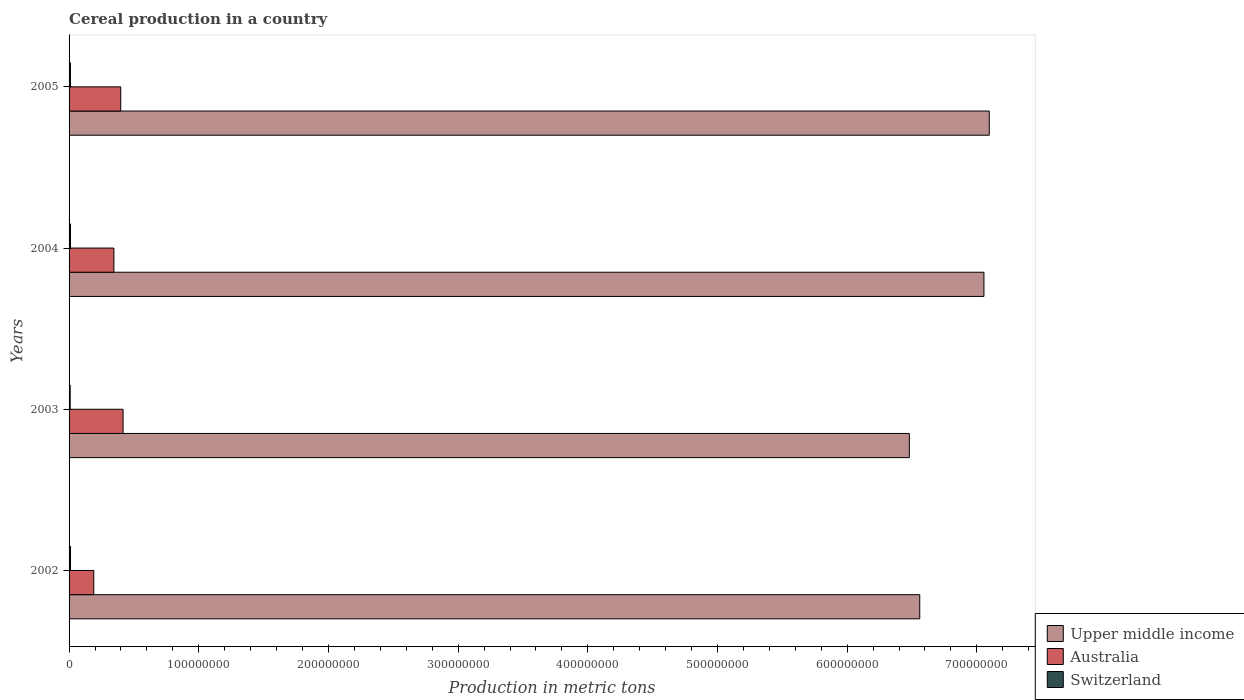How many different coloured bars are there?
Your response must be concise. 3. Are the number of bars on each tick of the Y-axis equal?
Offer a terse response. Yes. How many bars are there on the 2nd tick from the top?
Make the answer very short. 3. How many bars are there on the 2nd tick from the bottom?
Make the answer very short. 3. What is the total cereal production in Australia in 2003?
Provide a short and direct response. 4.16e+07. Across all years, what is the maximum total cereal production in Australia?
Ensure brevity in your answer.  4.16e+07. Across all years, what is the minimum total cereal production in Australia?
Offer a very short reply. 1.90e+07. What is the total total cereal production in Upper middle income in the graph?
Keep it short and to the point. 2.72e+09. What is the difference between the total cereal production in Switzerland in 2003 and that in 2005?
Give a very brief answer. -2.09e+05. What is the difference between the total cereal production in Upper middle income in 2003 and the total cereal production in Switzerland in 2002?
Your answer should be very brief. 6.47e+08. What is the average total cereal production in Switzerland per year?
Your answer should be very brief. 1.02e+06. In the year 2005, what is the difference between the total cereal production in Upper middle income and total cereal production in Australia?
Provide a short and direct response. 6.70e+08. What is the ratio of the total cereal production in Australia in 2004 to that in 2005?
Keep it short and to the point. 0.87. Is the total cereal production in Switzerland in 2002 less than that in 2005?
Your answer should be very brief. No. Is the difference between the total cereal production in Upper middle income in 2002 and 2004 greater than the difference between the total cereal production in Australia in 2002 and 2004?
Offer a very short reply. No. What is the difference between the highest and the second highest total cereal production in Switzerland?
Your answer should be compact. 1.20e+04. What is the difference between the highest and the lowest total cereal production in Upper middle income?
Keep it short and to the point. 6.16e+07. Is the sum of the total cereal production in Australia in 2002 and 2003 greater than the maximum total cereal production in Upper middle income across all years?
Offer a very short reply. No. What does the 3rd bar from the top in 2002 represents?
Provide a succinct answer. Upper middle income. What does the 2nd bar from the bottom in 2005 represents?
Keep it short and to the point. Australia. Is it the case that in every year, the sum of the total cereal production in Switzerland and total cereal production in Upper middle income is greater than the total cereal production in Australia?
Make the answer very short. Yes. Are all the bars in the graph horizontal?
Provide a short and direct response. Yes. How many years are there in the graph?
Your response must be concise. 4. Are the values on the major ticks of X-axis written in scientific E-notation?
Provide a short and direct response. No. Does the graph contain any zero values?
Make the answer very short. No. Does the graph contain grids?
Make the answer very short. No. Where does the legend appear in the graph?
Your answer should be compact. Bottom right. How many legend labels are there?
Ensure brevity in your answer.  3. How are the legend labels stacked?
Give a very brief answer. Vertical. What is the title of the graph?
Give a very brief answer. Cereal production in a country. Does "Timor-Leste" appear as one of the legend labels in the graph?
Make the answer very short. No. What is the label or title of the X-axis?
Your response must be concise. Production in metric tons. What is the Production in metric tons in Upper middle income in 2002?
Offer a terse response. 6.56e+08. What is the Production in metric tons in Australia in 2002?
Offer a terse response. 1.90e+07. What is the Production in metric tons of Switzerland in 2002?
Your response must be concise. 1.10e+06. What is the Production in metric tons in Upper middle income in 2003?
Offer a very short reply. 6.48e+08. What is the Production in metric tons in Australia in 2003?
Offer a very short reply. 4.16e+07. What is the Production in metric tons of Switzerland in 2003?
Ensure brevity in your answer.  8.47e+05. What is the Production in metric tons of Upper middle income in 2004?
Keep it short and to the point. 7.05e+08. What is the Production in metric tons in Australia in 2004?
Offer a very short reply. 3.46e+07. What is the Production in metric tons of Switzerland in 2004?
Offer a terse response. 1.09e+06. What is the Production in metric tons in Upper middle income in 2005?
Ensure brevity in your answer.  7.10e+08. What is the Production in metric tons of Australia in 2005?
Offer a terse response. 3.98e+07. What is the Production in metric tons in Switzerland in 2005?
Keep it short and to the point. 1.06e+06. Across all years, what is the maximum Production in metric tons in Upper middle income?
Your answer should be compact. 7.10e+08. Across all years, what is the maximum Production in metric tons in Australia?
Keep it short and to the point. 4.16e+07. Across all years, what is the maximum Production in metric tons of Switzerland?
Keep it short and to the point. 1.10e+06. Across all years, what is the minimum Production in metric tons in Upper middle income?
Make the answer very short. 6.48e+08. Across all years, what is the minimum Production in metric tons in Australia?
Your answer should be compact. 1.90e+07. Across all years, what is the minimum Production in metric tons in Switzerland?
Give a very brief answer. 8.47e+05. What is the total Production in metric tons of Upper middle income in the graph?
Offer a very short reply. 2.72e+09. What is the total Production in metric tons of Australia in the graph?
Your answer should be very brief. 1.35e+08. What is the total Production in metric tons in Switzerland in the graph?
Provide a short and direct response. 4.09e+06. What is the difference between the Production in metric tons of Upper middle income in 2002 and that in 2003?
Provide a succinct answer. 8.01e+06. What is the difference between the Production in metric tons in Australia in 2002 and that in 2003?
Offer a very short reply. -2.26e+07. What is the difference between the Production in metric tons of Switzerland in 2002 and that in 2003?
Provide a succinct answer. 2.54e+05. What is the difference between the Production in metric tons in Upper middle income in 2002 and that in 2004?
Your response must be concise. -4.95e+07. What is the difference between the Production in metric tons of Australia in 2002 and that in 2004?
Offer a terse response. -1.55e+07. What is the difference between the Production in metric tons of Switzerland in 2002 and that in 2004?
Make the answer very short. 1.20e+04. What is the difference between the Production in metric tons in Upper middle income in 2002 and that in 2005?
Your answer should be compact. -5.36e+07. What is the difference between the Production in metric tons of Australia in 2002 and that in 2005?
Ensure brevity in your answer.  -2.08e+07. What is the difference between the Production in metric tons in Switzerland in 2002 and that in 2005?
Ensure brevity in your answer.  4.45e+04. What is the difference between the Production in metric tons of Upper middle income in 2003 and that in 2004?
Your response must be concise. -5.75e+07. What is the difference between the Production in metric tons of Australia in 2003 and that in 2004?
Your response must be concise. 7.07e+06. What is the difference between the Production in metric tons of Switzerland in 2003 and that in 2004?
Keep it short and to the point. -2.42e+05. What is the difference between the Production in metric tons of Upper middle income in 2003 and that in 2005?
Ensure brevity in your answer.  -6.16e+07. What is the difference between the Production in metric tons of Australia in 2003 and that in 2005?
Your answer should be very brief. 1.79e+06. What is the difference between the Production in metric tons of Switzerland in 2003 and that in 2005?
Give a very brief answer. -2.09e+05. What is the difference between the Production in metric tons in Upper middle income in 2004 and that in 2005?
Your answer should be compact. -4.11e+06. What is the difference between the Production in metric tons in Australia in 2004 and that in 2005?
Provide a short and direct response. -5.28e+06. What is the difference between the Production in metric tons in Switzerland in 2004 and that in 2005?
Offer a terse response. 3.25e+04. What is the difference between the Production in metric tons of Upper middle income in 2002 and the Production in metric tons of Australia in 2003?
Your answer should be compact. 6.14e+08. What is the difference between the Production in metric tons in Upper middle income in 2002 and the Production in metric tons in Switzerland in 2003?
Keep it short and to the point. 6.55e+08. What is the difference between the Production in metric tons of Australia in 2002 and the Production in metric tons of Switzerland in 2003?
Your answer should be very brief. 1.82e+07. What is the difference between the Production in metric tons of Upper middle income in 2002 and the Production in metric tons of Australia in 2004?
Your answer should be compact. 6.21e+08. What is the difference between the Production in metric tons in Upper middle income in 2002 and the Production in metric tons in Switzerland in 2004?
Make the answer very short. 6.55e+08. What is the difference between the Production in metric tons in Australia in 2002 and the Production in metric tons in Switzerland in 2004?
Your answer should be very brief. 1.79e+07. What is the difference between the Production in metric tons of Upper middle income in 2002 and the Production in metric tons of Australia in 2005?
Provide a succinct answer. 6.16e+08. What is the difference between the Production in metric tons in Upper middle income in 2002 and the Production in metric tons in Switzerland in 2005?
Your response must be concise. 6.55e+08. What is the difference between the Production in metric tons in Australia in 2002 and the Production in metric tons in Switzerland in 2005?
Make the answer very short. 1.80e+07. What is the difference between the Production in metric tons of Upper middle income in 2003 and the Production in metric tons of Australia in 2004?
Your answer should be compact. 6.13e+08. What is the difference between the Production in metric tons in Upper middle income in 2003 and the Production in metric tons in Switzerland in 2004?
Your answer should be very brief. 6.47e+08. What is the difference between the Production in metric tons of Australia in 2003 and the Production in metric tons of Switzerland in 2004?
Offer a very short reply. 4.05e+07. What is the difference between the Production in metric tons in Upper middle income in 2003 and the Production in metric tons in Australia in 2005?
Keep it short and to the point. 6.08e+08. What is the difference between the Production in metric tons in Upper middle income in 2003 and the Production in metric tons in Switzerland in 2005?
Provide a short and direct response. 6.47e+08. What is the difference between the Production in metric tons of Australia in 2003 and the Production in metric tons of Switzerland in 2005?
Keep it short and to the point. 4.06e+07. What is the difference between the Production in metric tons in Upper middle income in 2004 and the Production in metric tons in Australia in 2005?
Make the answer very short. 6.66e+08. What is the difference between the Production in metric tons of Upper middle income in 2004 and the Production in metric tons of Switzerland in 2005?
Keep it short and to the point. 7.04e+08. What is the difference between the Production in metric tons in Australia in 2004 and the Production in metric tons in Switzerland in 2005?
Offer a terse response. 3.35e+07. What is the average Production in metric tons in Upper middle income per year?
Your response must be concise. 6.80e+08. What is the average Production in metric tons in Australia per year?
Make the answer very short. 3.38e+07. What is the average Production in metric tons of Switzerland per year?
Ensure brevity in your answer.  1.02e+06. In the year 2002, what is the difference between the Production in metric tons in Upper middle income and Production in metric tons in Australia?
Your response must be concise. 6.37e+08. In the year 2002, what is the difference between the Production in metric tons in Upper middle income and Production in metric tons in Switzerland?
Ensure brevity in your answer.  6.55e+08. In the year 2002, what is the difference between the Production in metric tons of Australia and Production in metric tons of Switzerland?
Make the answer very short. 1.79e+07. In the year 2003, what is the difference between the Production in metric tons in Upper middle income and Production in metric tons in Australia?
Provide a succinct answer. 6.06e+08. In the year 2003, what is the difference between the Production in metric tons in Upper middle income and Production in metric tons in Switzerland?
Offer a very short reply. 6.47e+08. In the year 2003, what is the difference between the Production in metric tons in Australia and Production in metric tons in Switzerland?
Offer a terse response. 4.08e+07. In the year 2004, what is the difference between the Production in metric tons in Upper middle income and Production in metric tons in Australia?
Give a very brief answer. 6.71e+08. In the year 2004, what is the difference between the Production in metric tons in Upper middle income and Production in metric tons in Switzerland?
Make the answer very short. 7.04e+08. In the year 2004, what is the difference between the Production in metric tons of Australia and Production in metric tons of Switzerland?
Your response must be concise. 3.35e+07. In the year 2005, what is the difference between the Production in metric tons in Upper middle income and Production in metric tons in Australia?
Make the answer very short. 6.70e+08. In the year 2005, what is the difference between the Production in metric tons in Upper middle income and Production in metric tons in Switzerland?
Keep it short and to the point. 7.09e+08. In the year 2005, what is the difference between the Production in metric tons of Australia and Production in metric tons of Switzerland?
Make the answer very short. 3.88e+07. What is the ratio of the Production in metric tons in Upper middle income in 2002 to that in 2003?
Provide a succinct answer. 1.01. What is the ratio of the Production in metric tons in Australia in 2002 to that in 2003?
Provide a succinct answer. 0.46. What is the ratio of the Production in metric tons in Switzerland in 2002 to that in 2003?
Your response must be concise. 1.3. What is the ratio of the Production in metric tons in Upper middle income in 2002 to that in 2004?
Your answer should be very brief. 0.93. What is the ratio of the Production in metric tons of Australia in 2002 to that in 2004?
Provide a succinct answer. 0.55. What is the ratio of the Production in metric tons in Upper middle income in 2002 to that in 2005?
Keep it short and to the point. 0.92. What is the ratio of the Production in metric tons in Australia in 2002 to that in 2005?
Provide a short and direct response. 0.48. What is the ratio of the Production in metric tons in Switzerland in 2002 to that in 2005?
Your answer should be compact. 1.04. What is the ratio of the Production in metric tons in Upper middle income in 2003 to that in 2004?
Give a very brief answer. 0.92. What is the ratio of the Production in metric tons of Australia in 2003 to that in 2004?
Offer a terse response. 1.2. What is the ratio of the Production in metric tons in Switzerland in 2003 to that in 2004?
Offer a terse response. 0.78. What is the ratio of the Production in metric tons in Upper middle income in 2003 to that in 2005?
Offer a terse response. 0.91. What is the ratio of the Production in metric tons of Australia in 2003 to that in 2005?
Provide a short and direct response. 1.04. What is the ratio of the Production in metric tons in Switzerland in 2003 to that in 2005?
Ensure brevity in your answer.  0.8. What is the ratio of the Production in metric tons of Australia in 2004 to that in 2005?
Give a very brief answer. 0.87. What is the ratio of the Production in metric tons in Switzerland in 2004 to that in 2005?
Your answer should be very brief. 1.03. What is the difference between the highest and the second highest Production in metric tons in Upper middle income?
Offer a terse response. 4.11e+06. What is the difference between the highest and the second highest Production in metric tons of Australia?
Make the answer very short. 1.79e+06. What is the difference between the highest and the second highest Production in metric tons of Switzerland?
Your response must be concise. 1.20e+04. What is the difference between the highest and the lowest Production in metric tons of Upper middle income?
Ensure brevity in your answer.  6.16e+07. What is the difference between the highest and the lowest Production in metric tons in Australia?
Offer a terse response. 2.26e+07. What is the difference between the highest and the lowest Production in metric tons of Switzerland?
Give a very brief answer. 2.54e+05. 